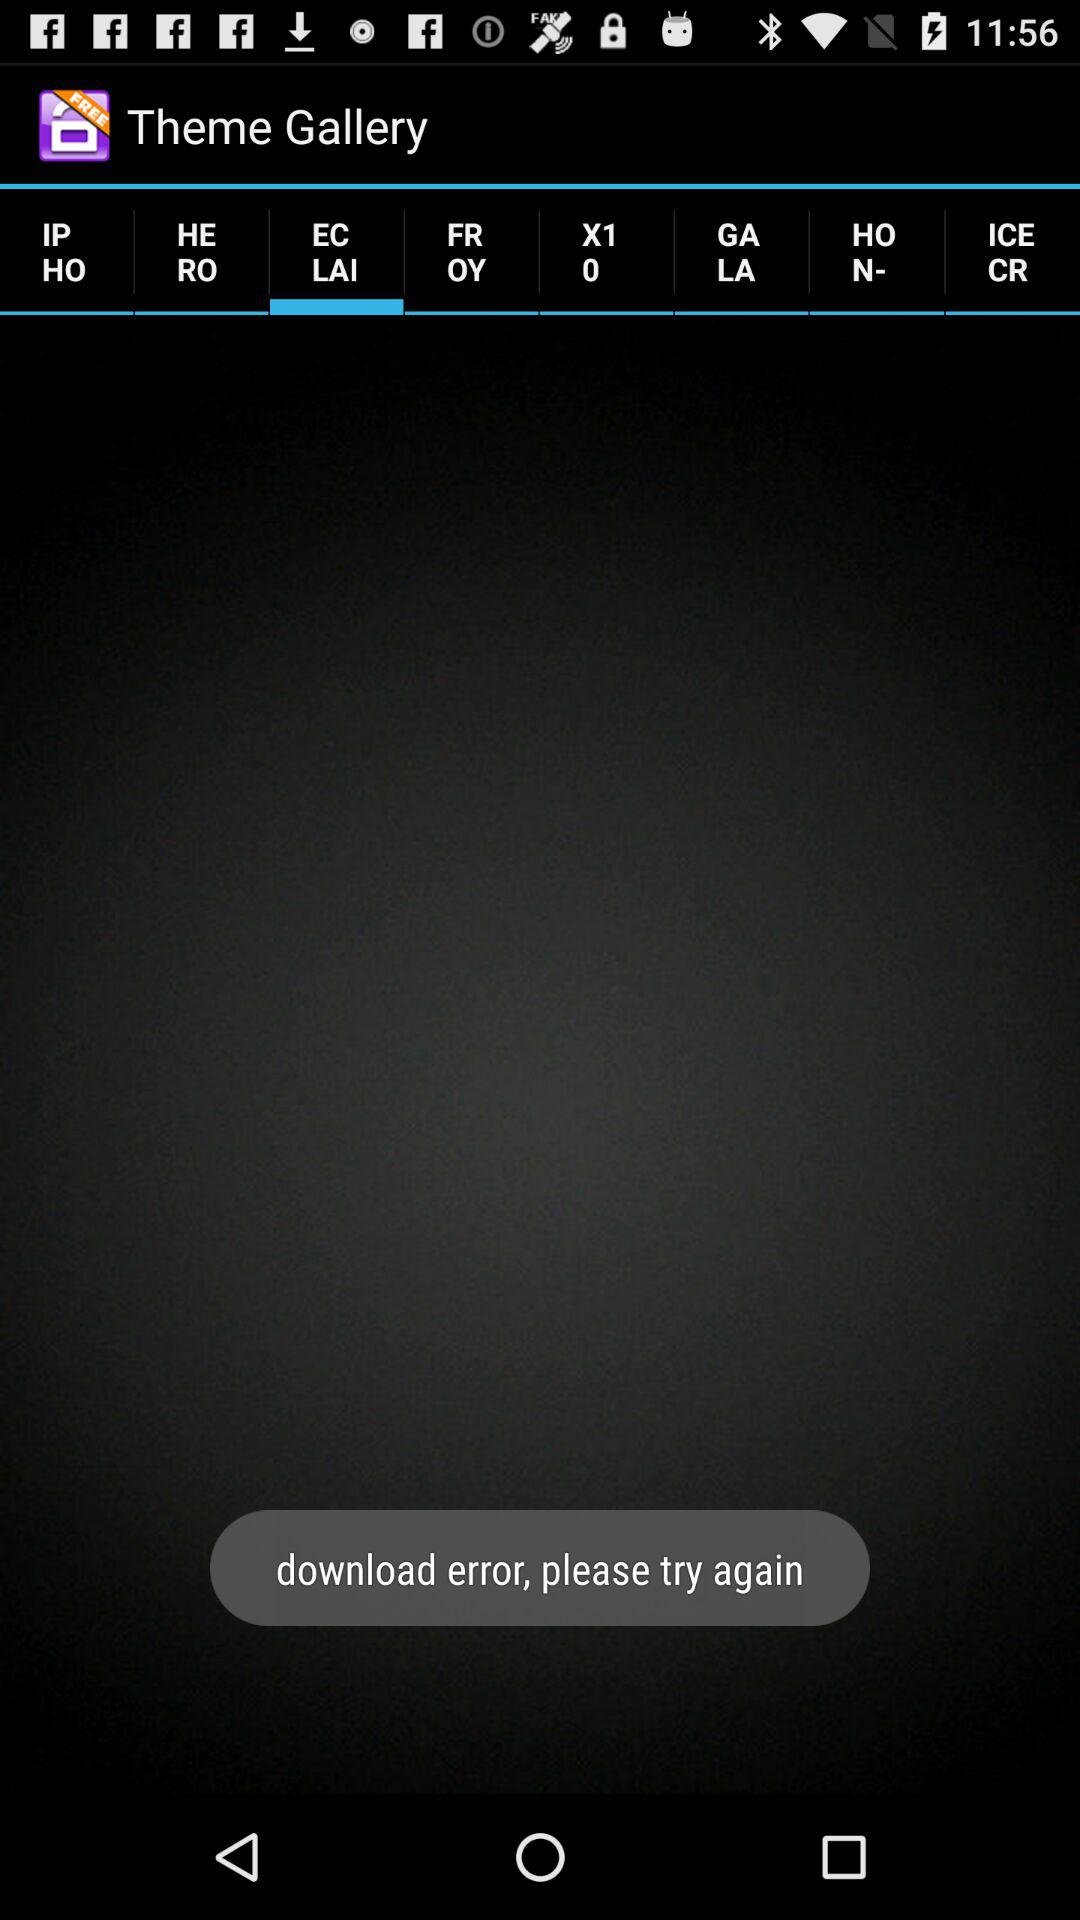Which tab is selected? The selected tab is "EC LAI". 